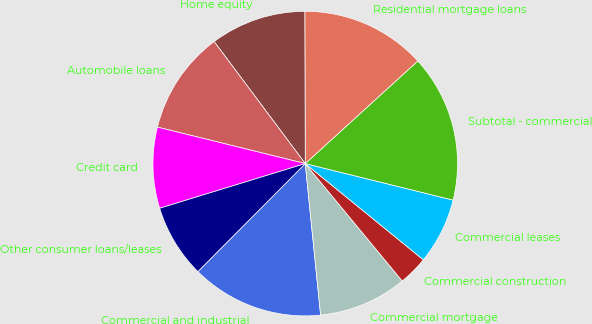Convert chart. <chart><loc_0><loc_0><loc_500><loc_500><pie_chart><fcel>Commercial and industrial<fcel>Commercial mortgage<fcel>Commercial construction<fcel>Commercial leases<fcel>Subtotal - commercial<fcel>Residential mortgage loans<fcel>Home equity<fcel>Automobile loans<fcel>Credit card<fcel>Other consumer loans/leases<nl><fcel>14.06%<fcel>9.38%<fcel>3.13%<fcel>7.03%<fcel>15.62%<fcel>13.28%<fcel>10.16%<fcel>10.94%<fcel>8.59%<fcel>7.81%<nl></chart> 